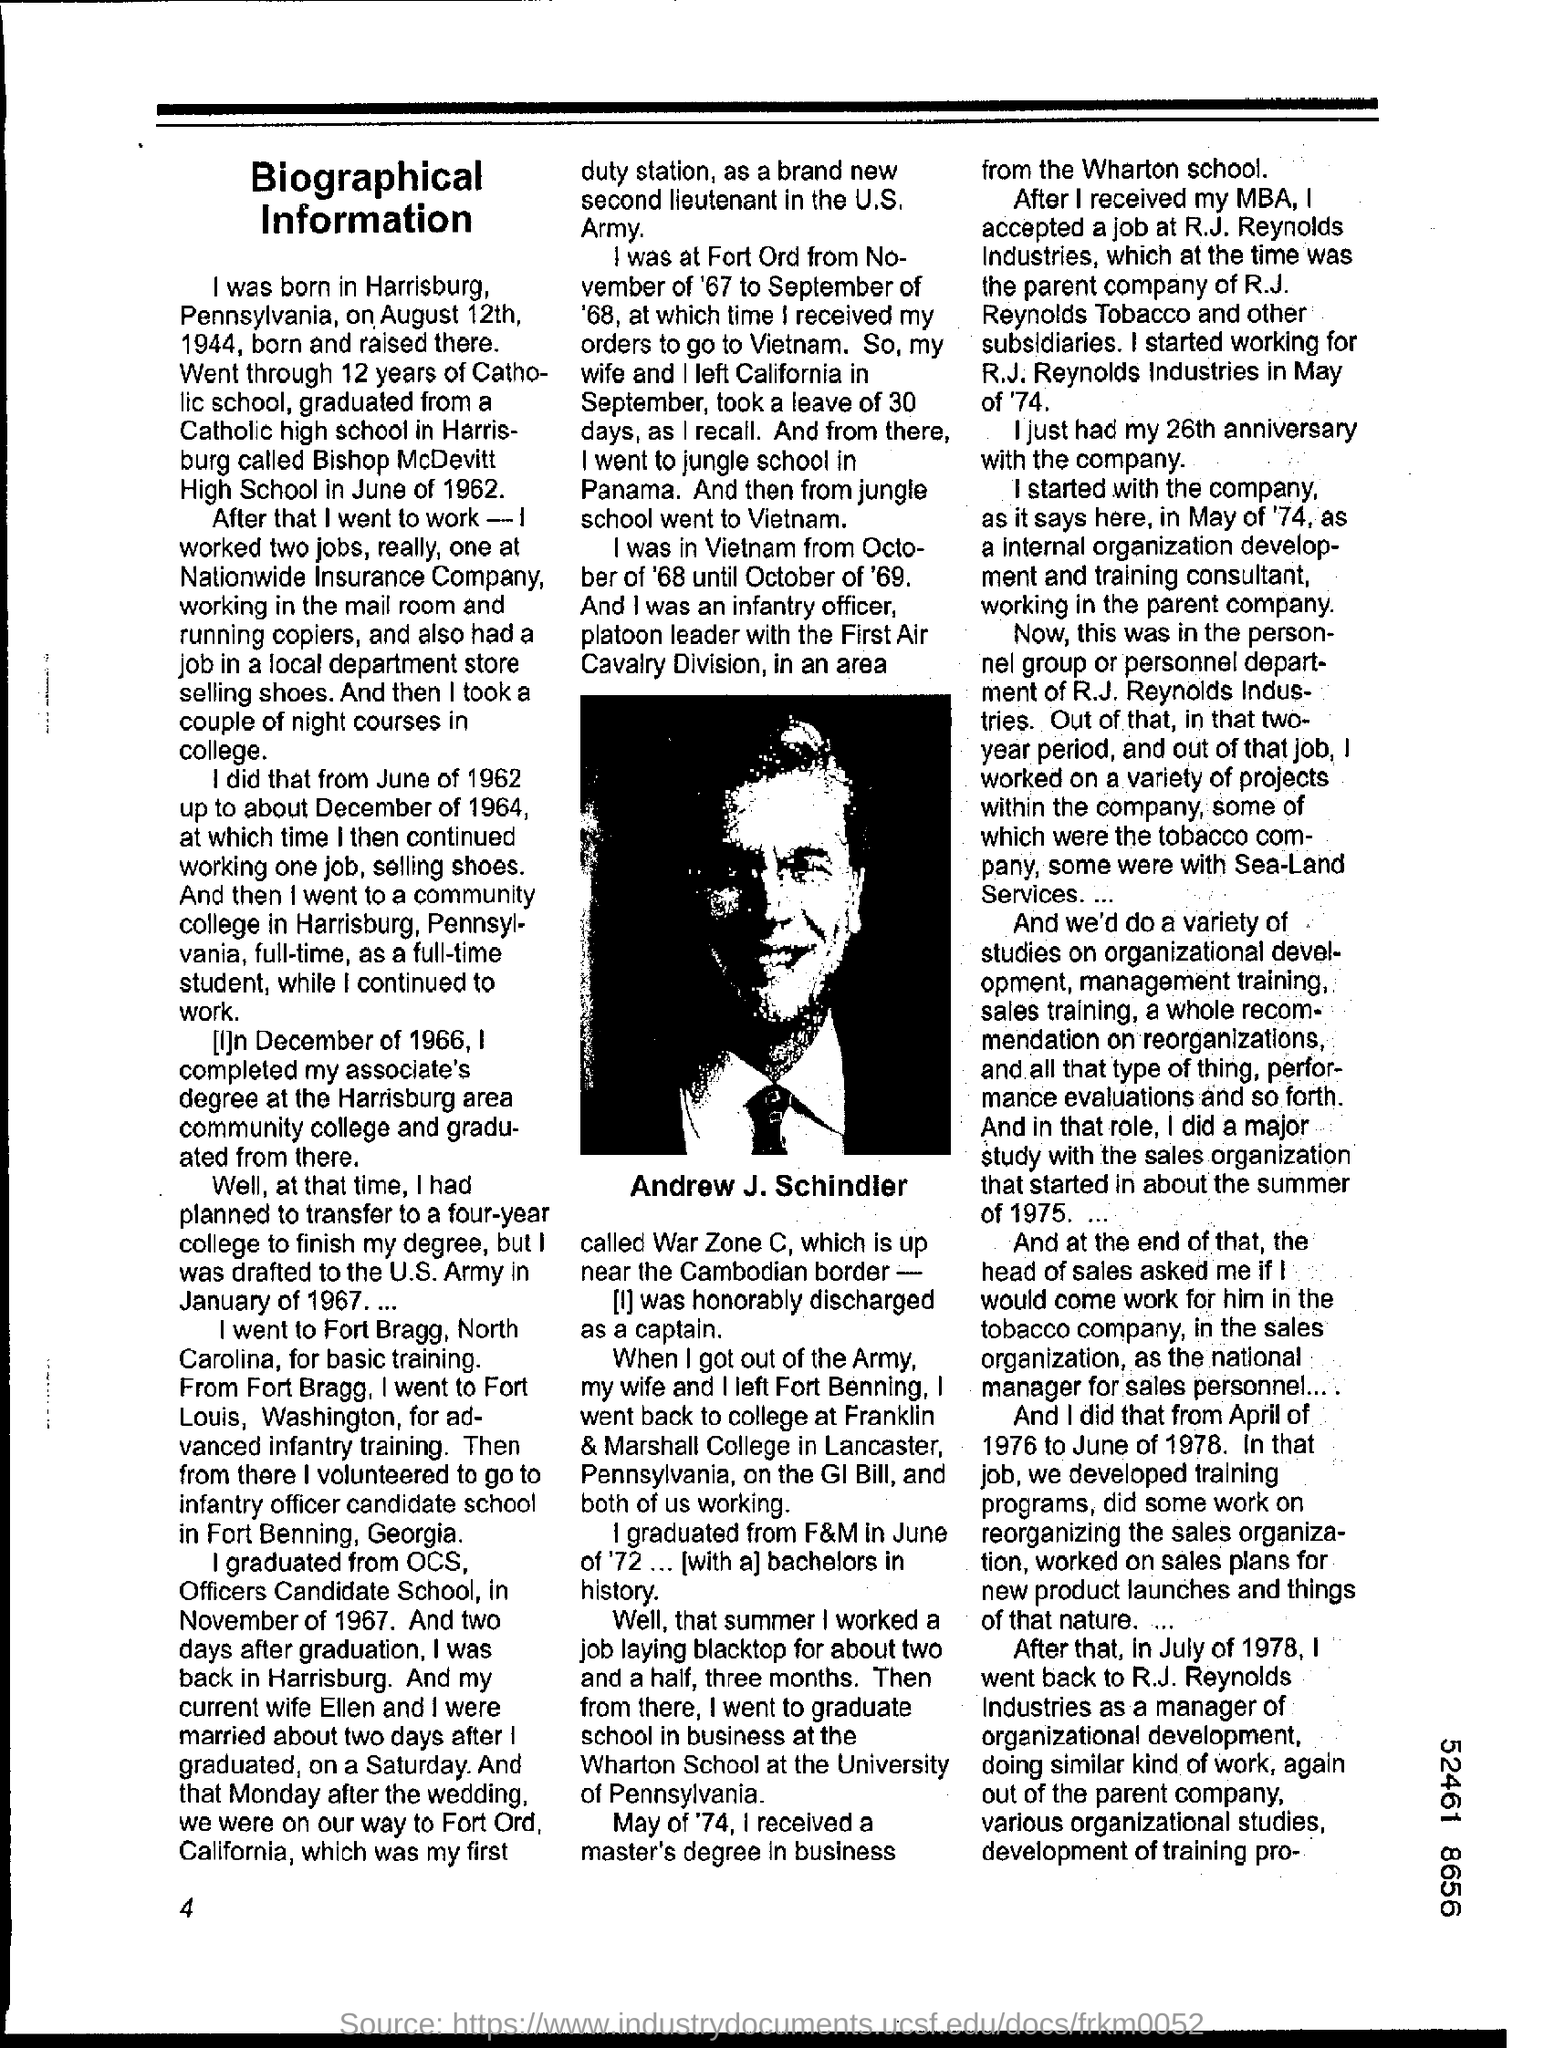Point out several critical features in this image. The person whose picture is shown is Andrew J. Schindler. 